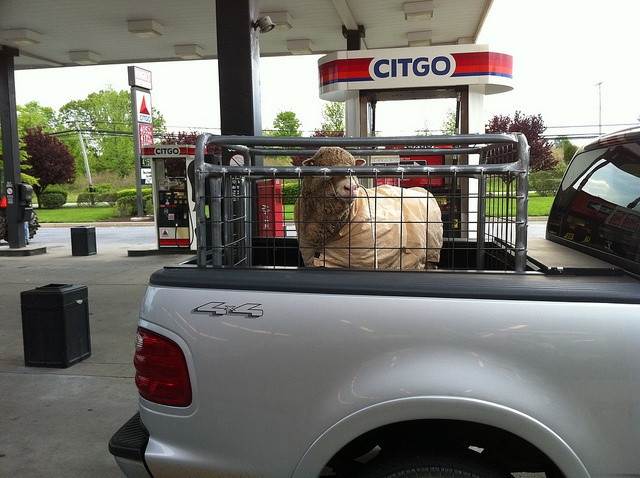Describe the objects in this image and their specific colors. I can see truck in black, gray, darkgray, and lightgray tones and sheep in black, beige, and maroon tones in this image. 